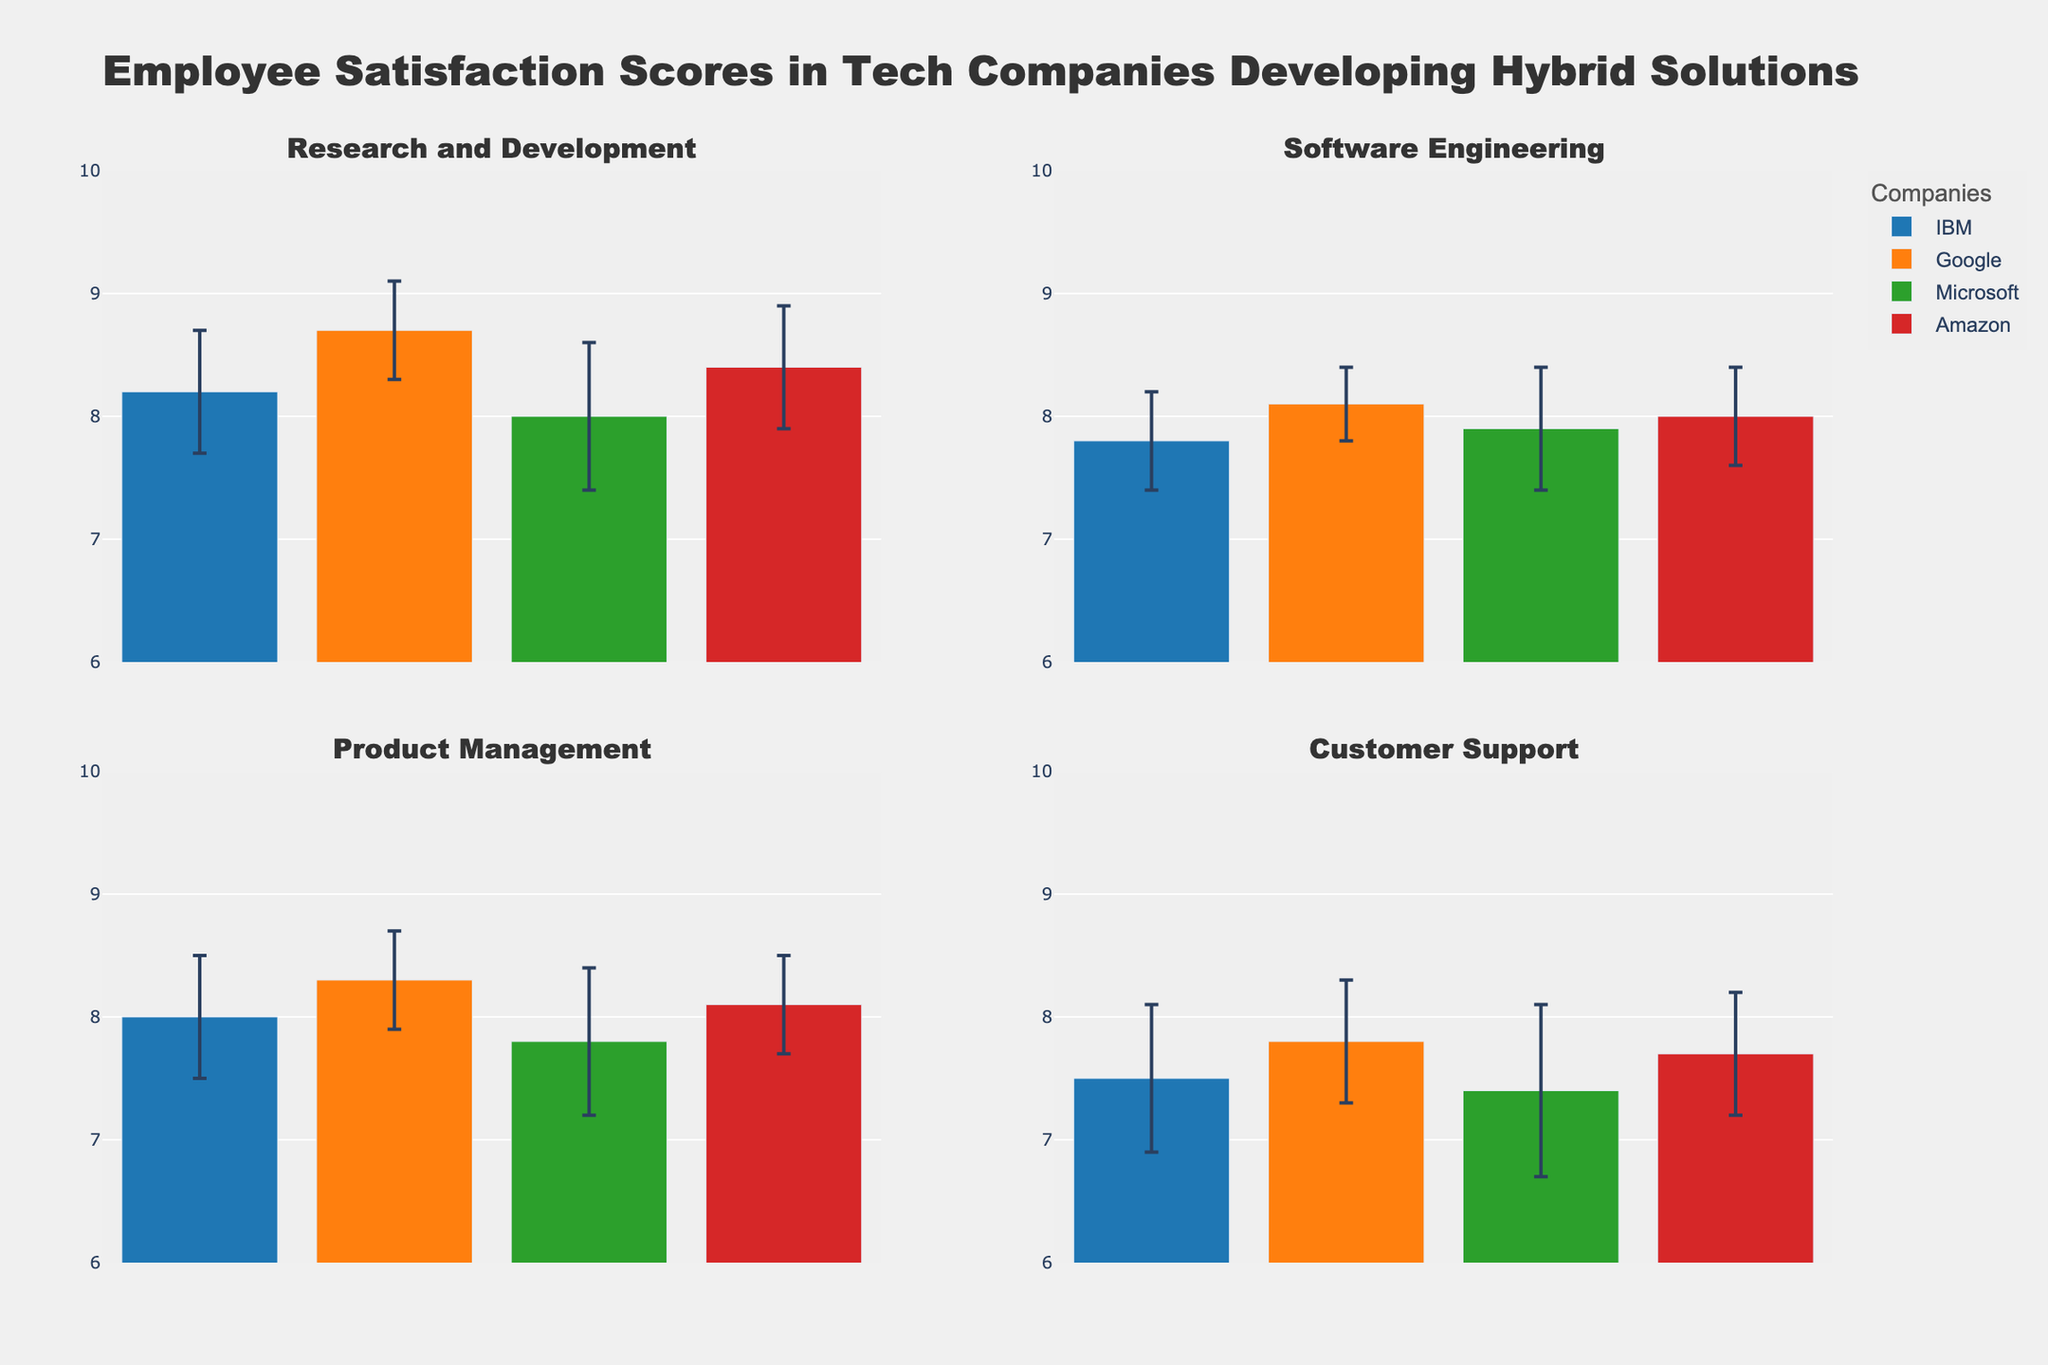How many departments are compared in the figure? The subplot titles represent different departments compared in the figure. Counting the unique titles, we see Research and Development, Software Engineering, Product Management, and Customer Support.
Answer: 4 Which company has the highest employee satisfaction score in Research and Development? In the subplot for Research and Development, the bar representing Google's employee satisfaction score is the highest, reaching 8.7.
Answer: Google What is the range of the y-axis used in the subplots? Observing the y-axis labels on the subplots, we note that they range from 6 to 10.
Answer: 6 to 10 Which department has the lowest satisfaction score for Microsoft? By examining the subplots, we observe the bars representing Microsoft's scores. The lowest score is in the Customer Support department at 7.4.
Answer: Customer Support What is the difference in mean satisfaction scores between Google and Amazon in Product Management? From the Product Management subplot, Google's mean score is 8.3 and Amazon's is 8.1. Subtracting these gives us the difference: 8.3 - 8.1.
Answer: 0.2 Which department has the most significant standard error for Microsoft? Reviewing the error bars in each subplot for Microsoft, the Customer Support department shows the largest standard error at 0.7.
Answer: Customer Support Compare the mean satisfaction scores for Software Engineering across all companies. Which company has the highest score? In the Software Engineering subplot, the mean scores are 7.8 (IBM), 8.1 (Google), 7.9 (Microsoft), and 8.0 (Amazon). Google has the highest score at 8.1.
Answer: Google In which department is the gap between the highest and lowest satisfaction scores the smallest, and which companies do they belong to? Checking the subplots, in Product Management, the range between the highest and lowest scores (8.3 for Google and 7.8 for Microsoft) is 0.5, the smallest among all departments.
Answer: Product Management (Google and Microsoft) What is the total mean employee satisfaction score for IBM across all departments? Summing IBM's mean scores from all subplots: 8.2 (R&D), 7.8 (Software Eng), 8.0 (Product Management), 7.5 (Customer Support) gives us 31.5.
Answer: 31.5 Which department shows the largest standard error on average across all companies? Calculating the average standard error for each department, Customer Support shows the largest average: IBM (0.6), Google (0.5), Microsoft (0.7), Amazon (0.5) average to 0.575.
Answer: Customer Support 